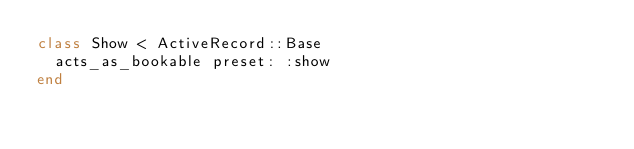Convert code to text. <code><loc_0><loc_0><loc_500><loc_500><_Ruby_>class Show < ActiveRecord::Base
  acts_as_bookable preset: :show
end
</code> 